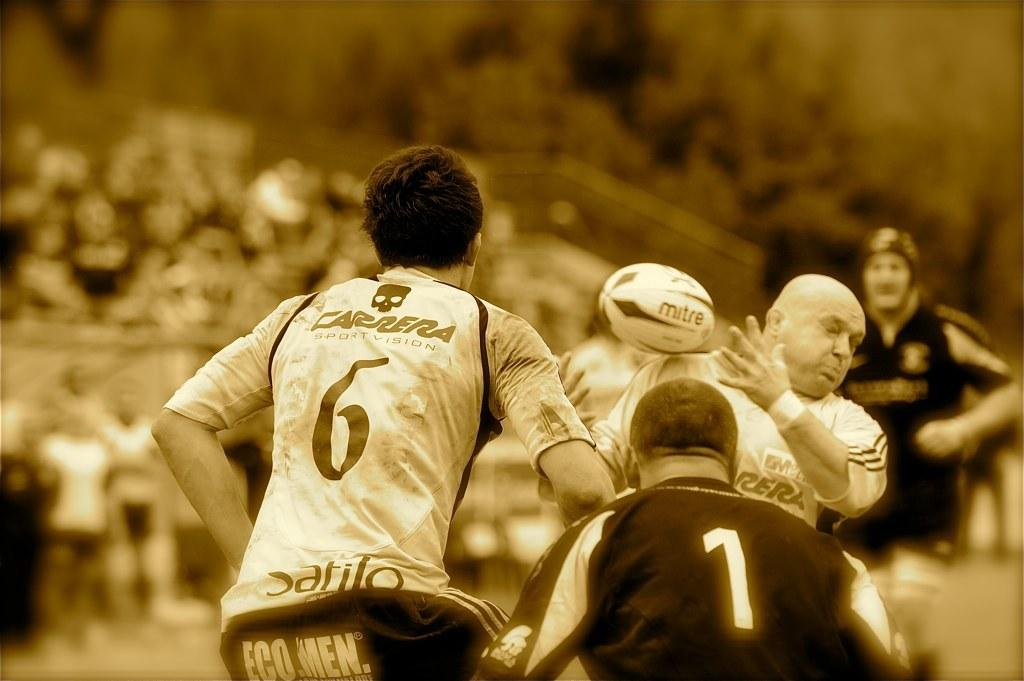<image>
Describe the image concisely. sport players with one wearing a white shirt that says the number 6 on it 